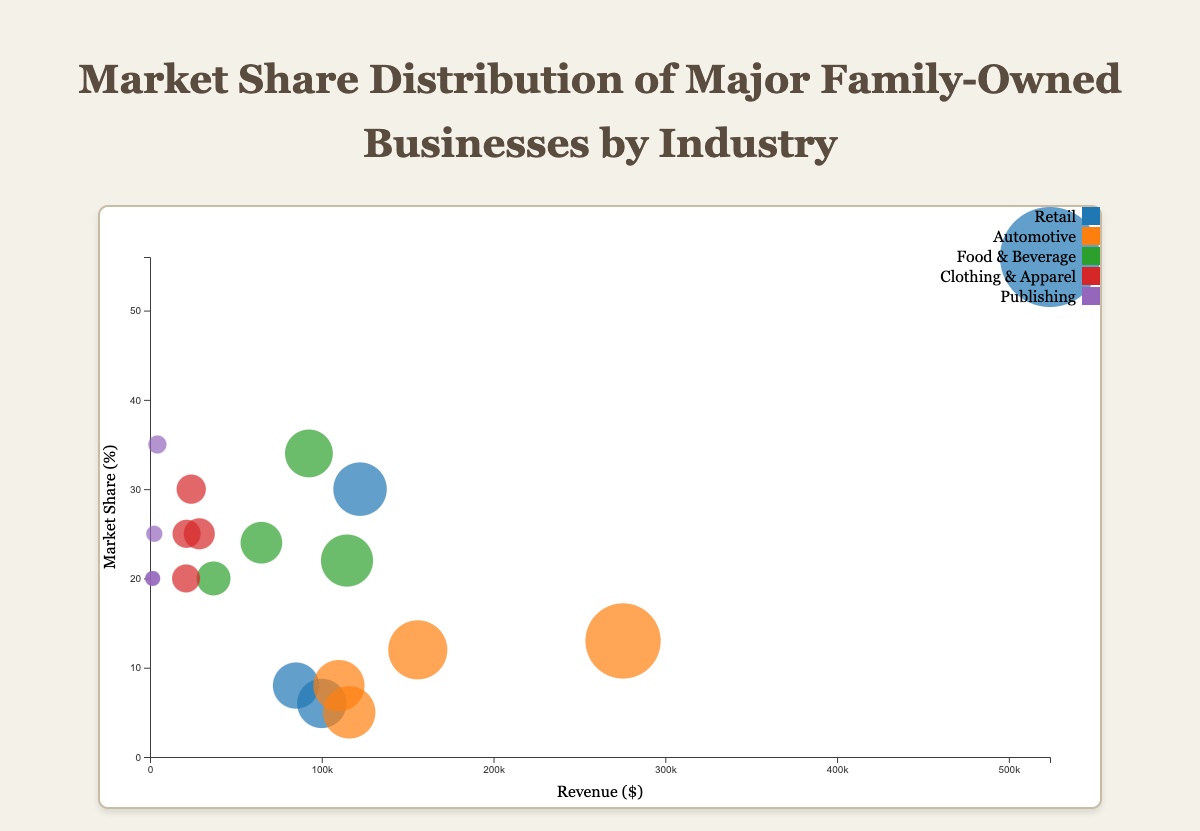What is the title of the chart? The title of the chart is displayed at the top and reads "Market Share Distribution of Major Family-Owned Businesses by Industry".
Answer: Market Share Distribution of Major Family-Owned Businesses by Industry Which industry has the company with the highest market share? By observing the bubble chart, you can see that Walmart in the Retail industry has the highest market share percentage at 56%.
Answer: Retail How many companies are represented in the Retail industry? By counting the bubbles associated with the Retail industry color in the chart, there are 4 companies in the Retail industry.
Answer: 4 What is the revenue of the company with a 35% market share in the Publishing industry? By identifying the bubble with a 35% market share within the Publishing industry, you can see Penguin Random House has a revenue of $4,300.
Answer: $4,300 Which company has the smallest market share in the Automotive industry? By identifying the smallest bubble along the y-axis in the Automotive industry, BMW has the smallest market share at 5%.
Answer: BMW What is the combined market share of the companies in the Clothing & Apparel industry? Adding up the market shares of Zara (25%), H&M (30%), Uniqlo (20%), and Fast Retailing Co., Ltd. (25%) gives a total of 100%.
Answer: 100% Which industry has the most evenly distributed market shares among its companies? The Clothing & Apparel industry companies have market shares of 25%, 30%, 20%, and 25%, which are relatively close compared to other industries.
Answer: Clothing & Apparel Which company has the largest bubble size and what does it represent? The largest bubble in the chart represents Walmart in the Retail industry, indicating it has the highest revenue of $523,964.
Answer: Walmart What is the difference in revenue between the companies with the highest and lowest market shares in the Food & Beverage industry? The company with the highest market share in Food & Beverage is Nestlé ($92,518), and the lowest is Mars, Inc. ($37,000). The difference in revenue is $92,518 - $37,000 = $55,518.
Answer: $55,518 